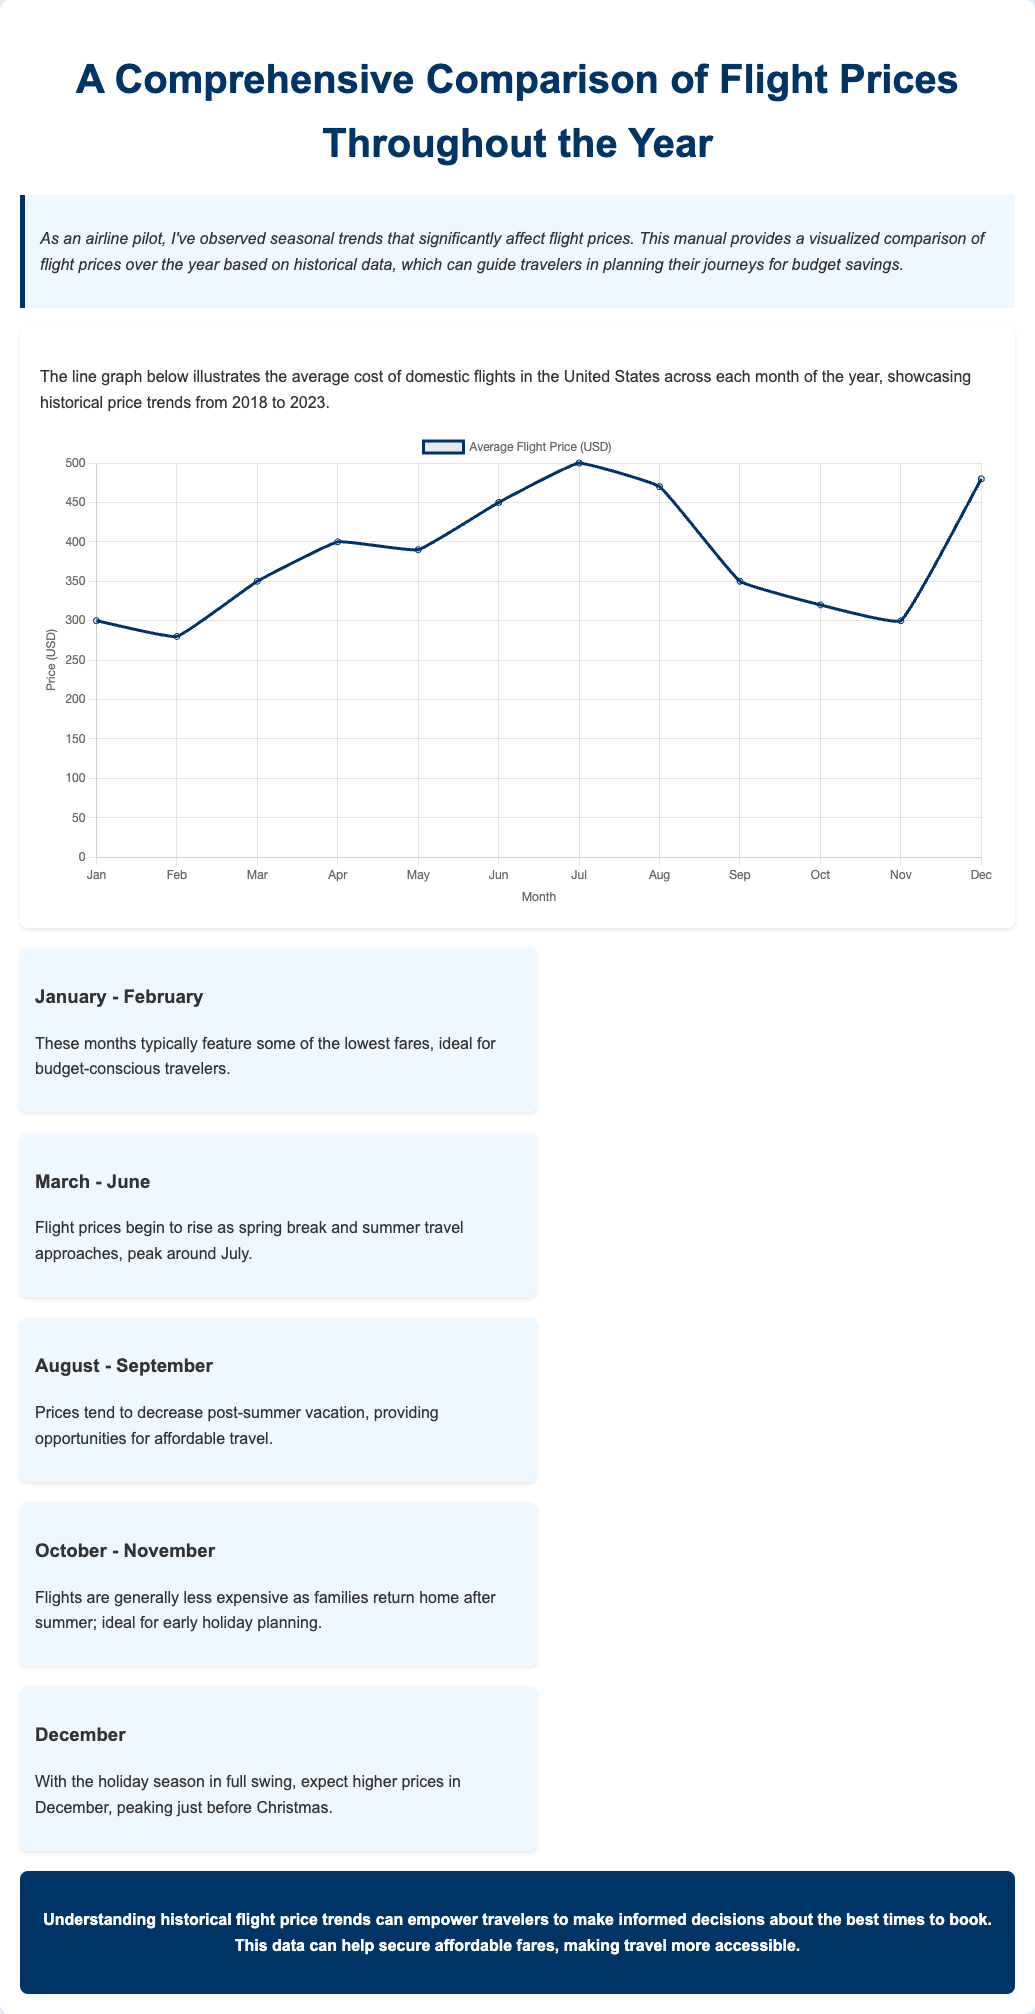What is the title of the document? The title of the document is stated at the top of the content, showcasing its main theme.
Answer: A Comprehensive Comparison of Flight Prices Throughout the Year How many datasets are visualized in the line graph? The line graph contains one dataset that represents average flight prices over the months.
Answer: One What month shows the highest average flight price? The specific month with the highest price is identified in the data visualized within the graph.
Answer: July Which months offer the cheapest fares according to the insights? The insights specify the months characterized by lower flight prices for budget travelers.
Answer: January - February What price did average flights reach in December? The document provides the average price of flights in December based on historical data.
Answer: 480 In which month is the trend expected to peak? Insights from the document indicate the month when flight prices are anticipated to reach their highest point.
Answer: July What is the overall conclusion the pilot shares about flight prices? The conclusion summarizes the purpose and benefits of understanding the trends in flight pricing.
Answer: Understanding historical flight price trends can empower travelers to make informed decisions about the best times to book What is the average flight price in March? The document lists the average price for flights in March as part of the data representation.
Answer: 350 